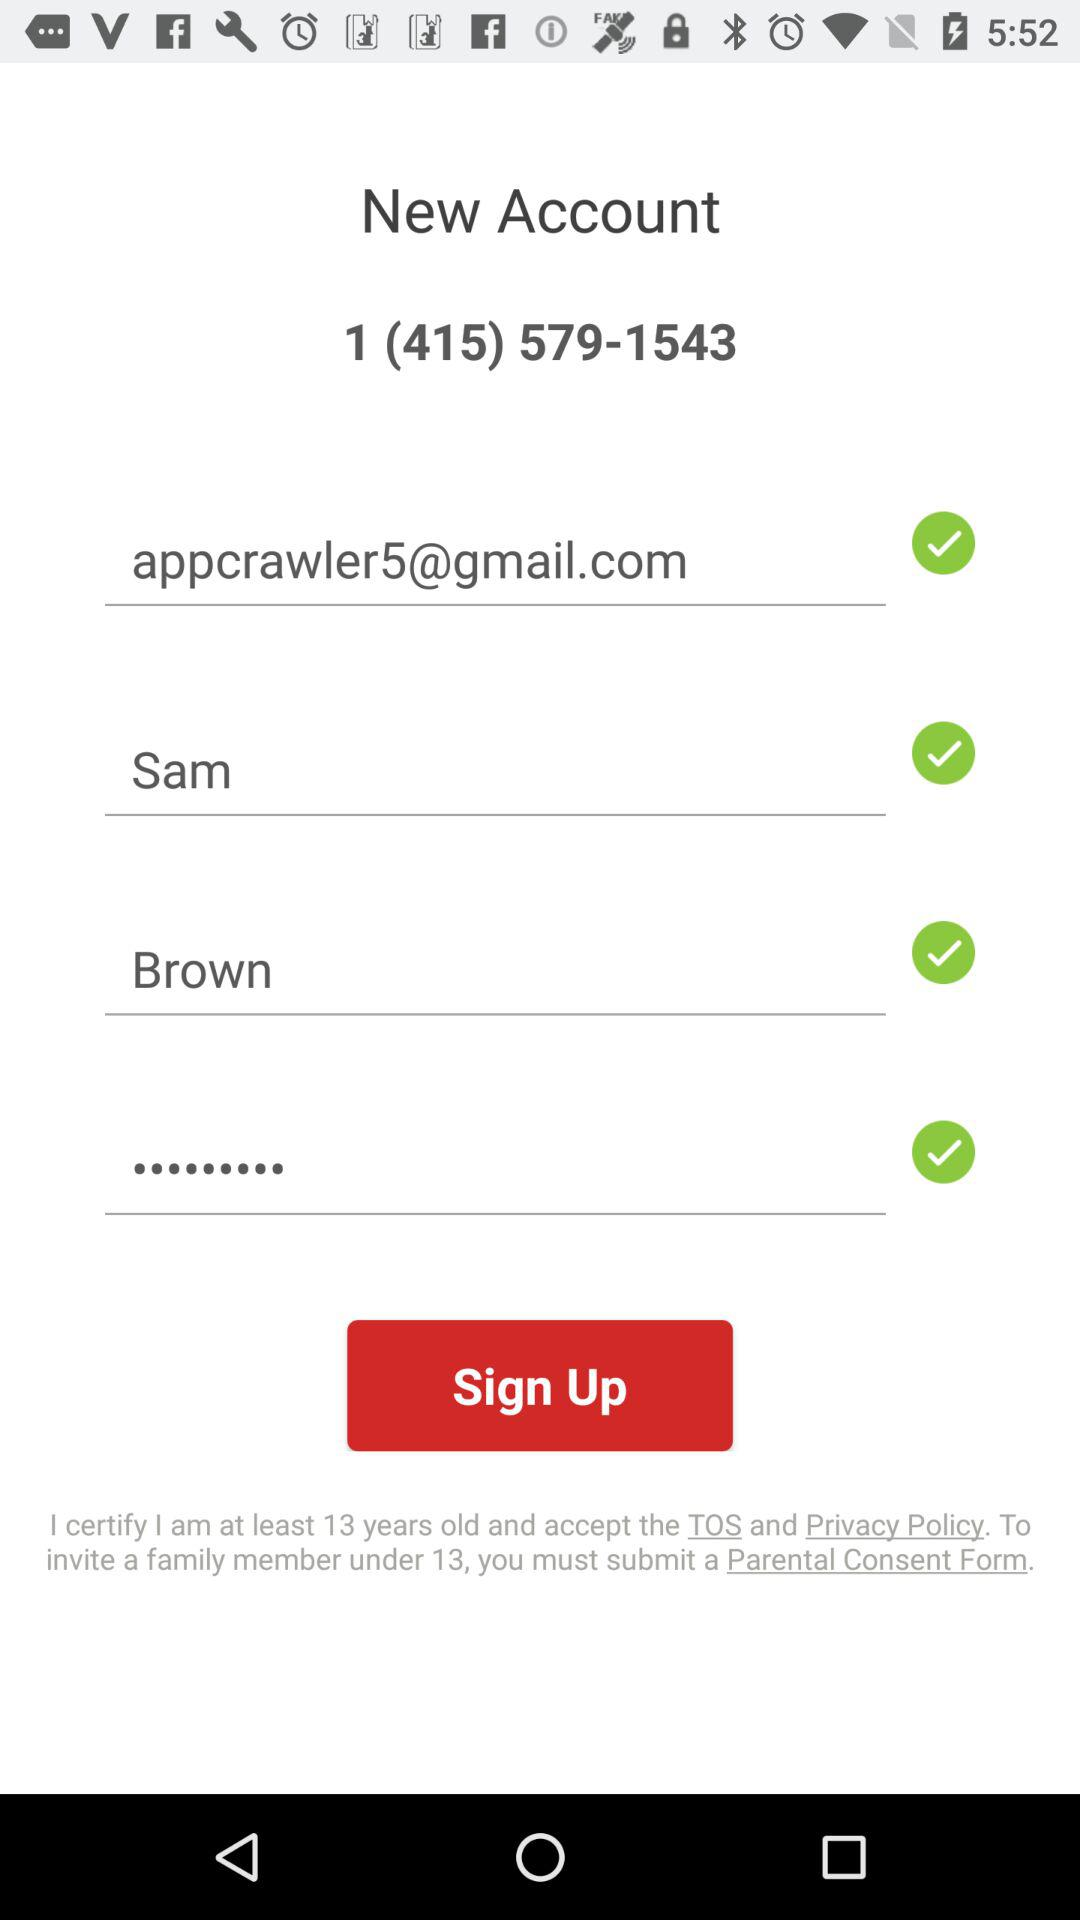What is the age limit given for creating the account? The given age limit is at least 13 years old. 